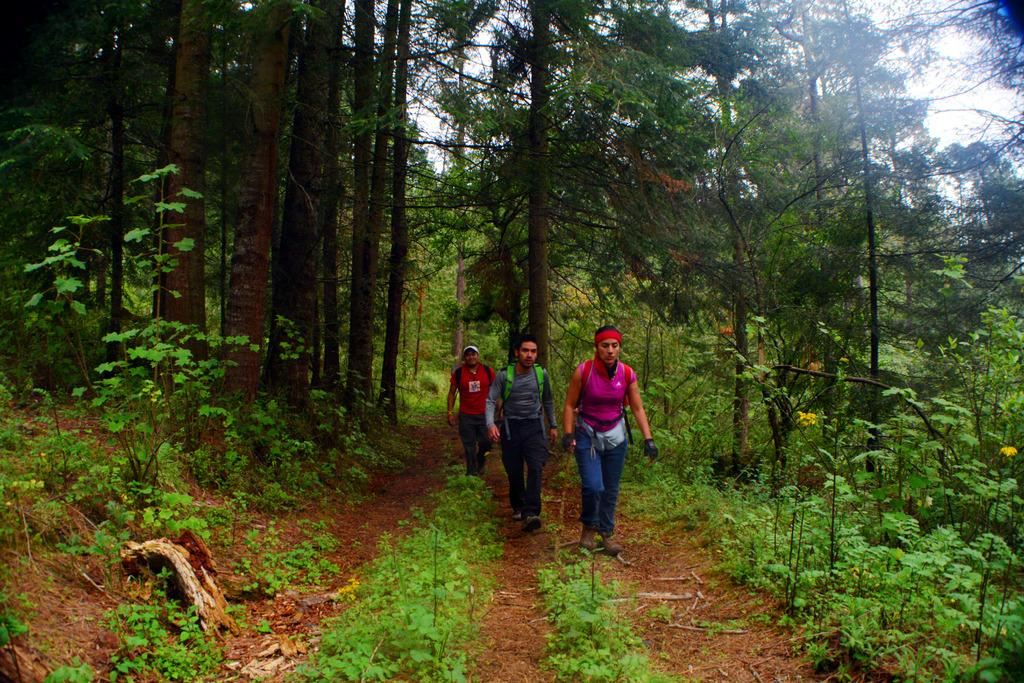How many people are in the foreground of the picture? There are three men in the foreground of the picture. What are the men doing in the image? The men are walking on the ground. What can be seen in the background of the picture? There are trees and the sky visible in the background of the picture. What type of ring can be seen on the men's fingers in the image? There are no rings visible on the men's fingers in the image. What year is depicted in the image? The image does not depict a specific year; it is a photograph of three men walking on the ground. 